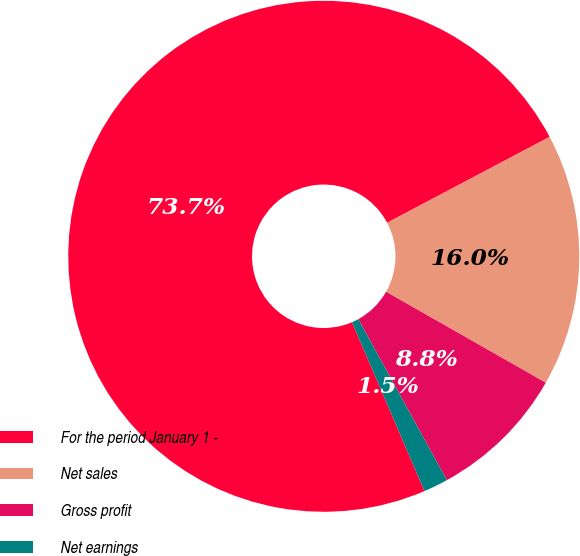Convert chart to OTSL. <chart><loc_0><loc_0><loc_500><loc_500><pie_chart><fcel>For the period January 1 -<fcel>Net sales<fcel>Gross profit<fcel>Net earnings<nl><fcel>73.71%<fcel>15.98%<fcel>8.76%<fcel>1.55%<nl></chart> 